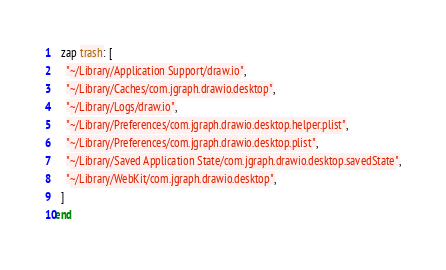<code> <loc_0><loc_0><loc_500><loc_500><_Ruby_>
  zap trash: [
    "~/Library/Application Support/draw.io",
    "~/Library/Caches/com.jgraph.drawio.desktop",
    "~/Library/Logs/draw.io",
    "~/Library/Preferences/com.jgraph.drawio.desktop.helper.plist",
    "~/Library/Preferences/com.jgraph.drawio.desktop.plist",
    "~/Library/Saved Application State/com.jgraph.drawio.desktop.savedState",
    "~/Library/WebKit/com.jgraph.drawio.desktop",
  ]
end
</code> 